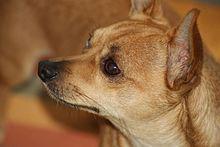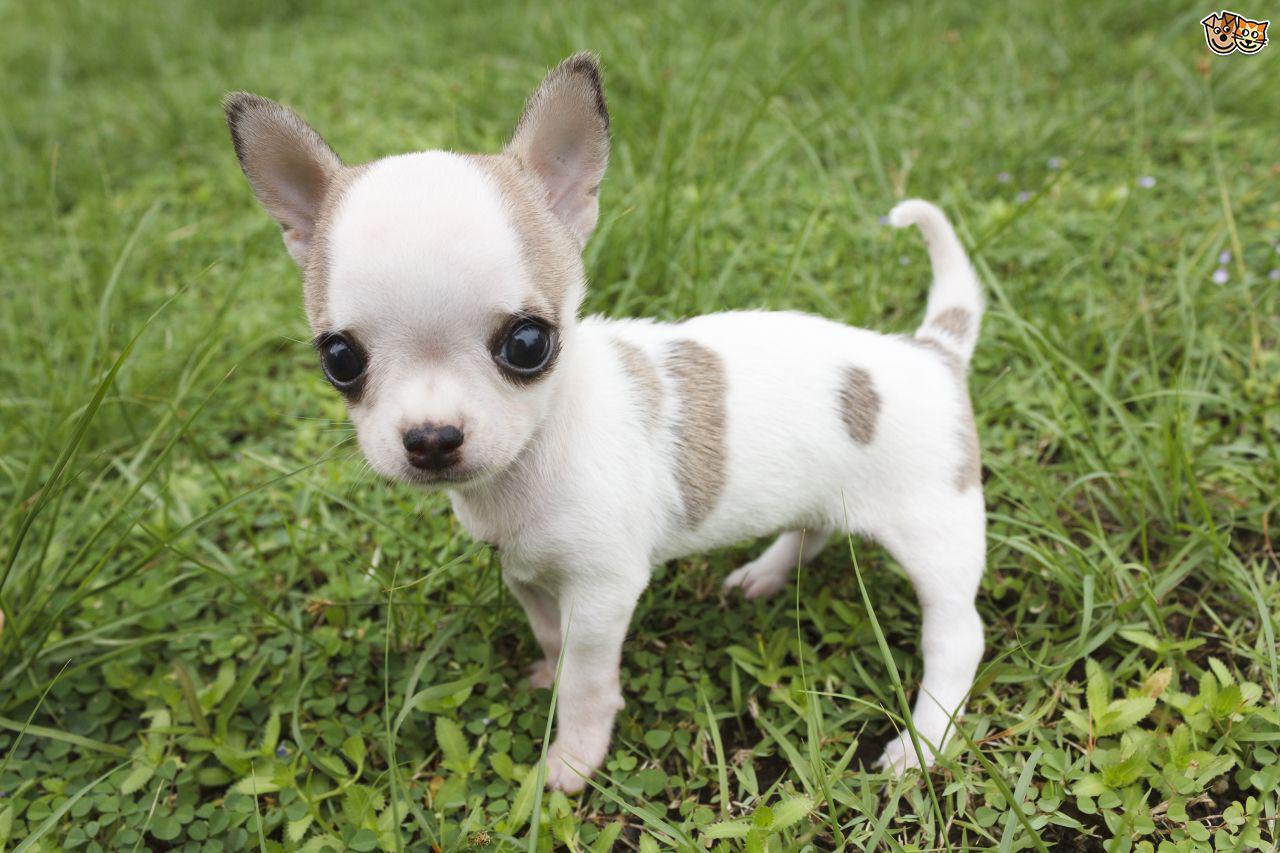The first image is the image on the left, the second image is the image on the right. For the images shown, is this caption "There are two chihuahuas with their heads to the right and tails up to the left." true? Answer yes or no. No. 